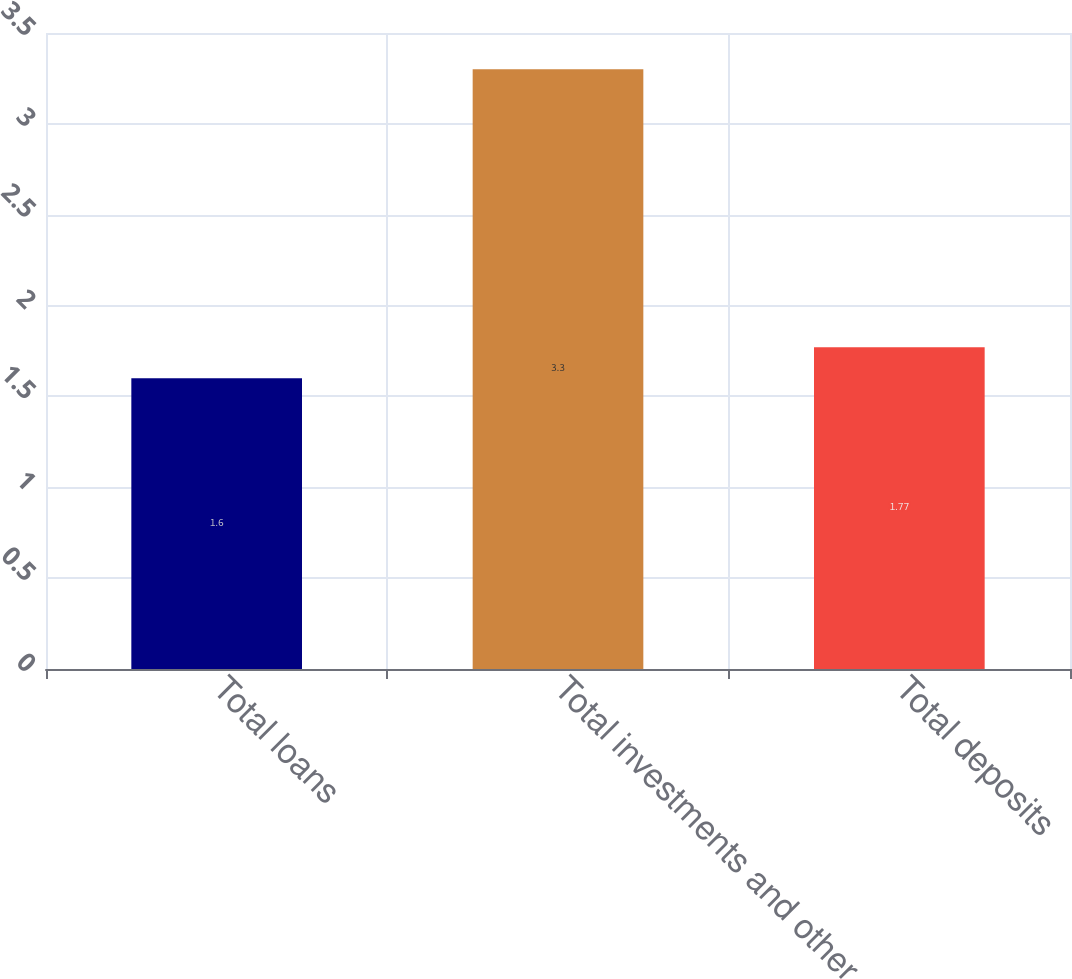<chart> <loc_0><loc_0><loc_500><loc_500><bar_chart><fcel>Total loans<fcel>Total investments and other<fcel>Total deposits<nl><fcel>1.6<fcel>3.3<fcel>1.77<nl></chart> 